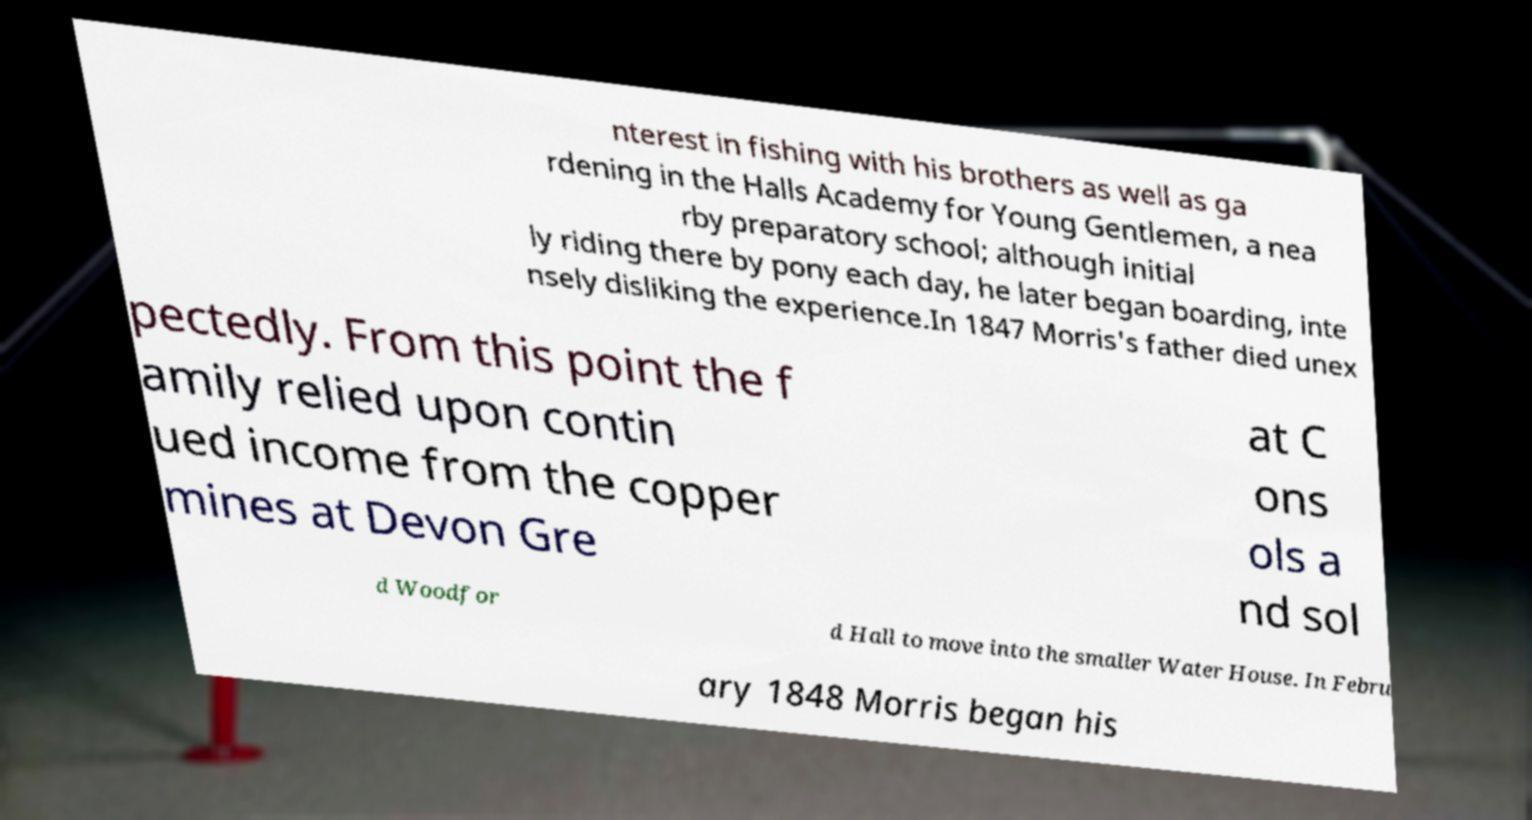I need the written content from this picture converted into text. Can you do that? nterest in fishing with his brothers as well as ga rdening in the Halls Academy for Young Gentlemen, a nea rby preparatory school; although initial ly riding there by pony each day, he later began boarding, inte nsely disliking the experience.In 1847 Morris's father died unex pectedly. From this point the f amily relied upon contin ued income from the copper mines at Devon Gre at C ons ols a nd sol d Woodfor d Hall to move into the smaller Water House. In Febru ary 1848 Morris began his 